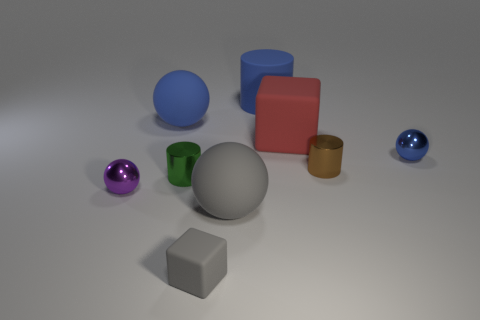There is a shiny thing that is the same color as the matte cylinder; what size is it?
Your response must be concise. Small. What is the color of the big object that is the same shape as the tiny green shiny thing?
Offer a terse response. Blue. How many things are either big rubber things or tiny brown things?
Give a very brief answer. 5. Do the big blue thing that is to the left of the green object and the large gray matte object in front of the small green metal thing have the same shape?
Your answer should be very brief. Yes. What shape is the blue rubber object that is behind the large blue rubber ball?
Provide a succinct answer. Cylinder. Are there the same number of tiny gray rubber objects that are on the right side of the blue rubber cylinder and brown cylinders behind the small blue metallic thing?
Make the answer very short. Yes. How many objects are either tiny metal spheres or rubber spheres that are behind the purple object?
Ensure brevity in your answer.  3. There is a small object that is both to the left of the red object and on the right side of the green object; what shape is it?
Ensure brevity in your answer.  Cube. There is a brown cylinder in front of the metal object behind the small brown shiny thing; what is its material?
Keep it short and to the point. Metal. Is the material of the small object that is in front of the gray matte sphere the same as the small green cylinder?
Offer a very short reply. No. 